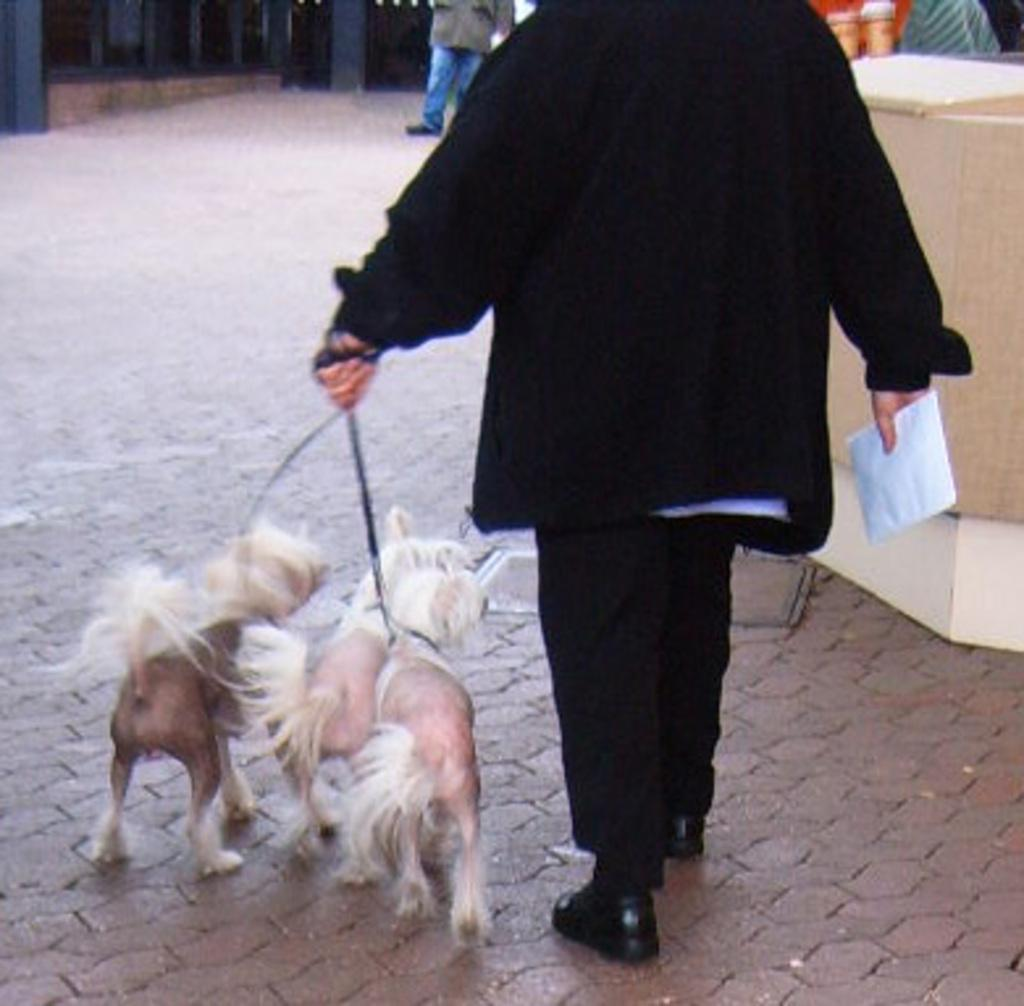What is the person holding in the image? The person is holding leashes of three dogs and a paper in the image. Can you describe the wooden object on the right side of the image? Unfortunately, the provided facts do not mention any specific details about the wooden object. What is visible at the top of the image? There is a person and objects visible at the top of the image. What type of badge is the person wearing on their body in the image? There is no mention of a badge or any clothing item in the provided facts, so we cannot determine if the person is wearing a badge or not. 